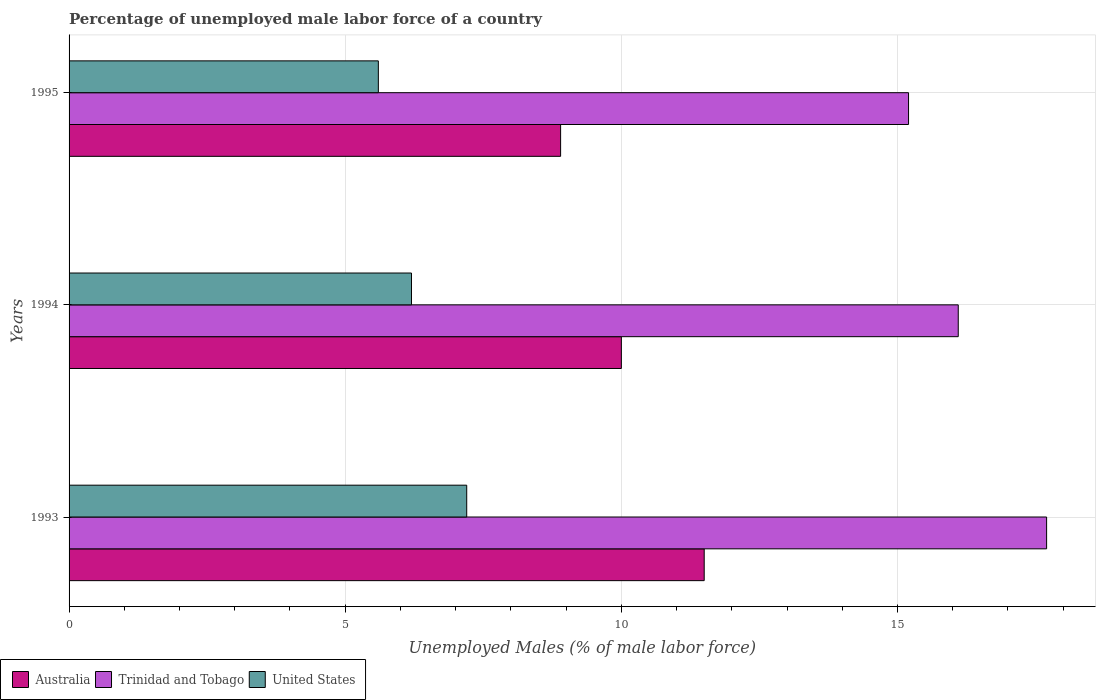How many different coloured bars are there?
Provide a succinct answer. 3. How many bars are there on the 3rd tick from the top?
Make the answer very short. 3. How many bars are there on the 3rd tick from the bottom?
Offer a very short reply. 3. In how many cases, is the number of bars for a given year not equal to the number of legend labels?
Ensure brevity in your answer.  0. What is the percentage of unemployed male labor force in United States in 1995?
Your response must be concise. 5.6. Across all years, what is the maximum percentage of unemployed male labor force in Trinidad and Tobago?
Ensure brevity in your answer.  17.7. Across all years, what is the minimum percentage of unemployed male labor force in Trinidad and Tobago?
Make the answer very short. 15.2. What is the total percentage of unemployed male labor force in Trinidad and Tobago in the graph?
Provide a succinct answer. 49. What is the difference between the percentage of unemployed male labor force in United States in 1994 and that in 1995?
Offer a terse response. 0.6. What is the difference between the percentage of unemployed male labor force in Australia in 1994 and the percentage of unemployed male labor force in Trinidad and Tobago in 1995?
Your response must be concise. -5.2. What is the average percentage of unemployed male labor force in Trinidad and Tobago per year?
Give a very brief answer. 16.33. In the year 1994, what is the difference between the percentage of unemployed male labor force in Australia and percentage of unemployed male labor force in United States?
Make the answer very short. 3.8. In how many years, is the percentage of unemployed male labor force in Australia greater than 10 %?
Your response must be concise. 1. What is the ratio of the percentage of unemployed male labor force in Trinidad and Tobago in 1993 to that in 1994?
Give a very brief answer. 1.1. Is the percentage of unemployed male labor force in Trinidad and Tobago in 1993 less than that in 1994?
Provide a short and direct response. No. What is the difference between the highest and the lowest percentage of unemployed male labor force in Trinidad and Tobago?
Provide a succinct answer. 2.5. What does the 3rd bar from the top in 1993 represents?
Your answer should be compact. Australia. What does the 1st bar from the bottom in 1994 represents?
Offer a terse response. Australia. Is it the case that in every year, the sum of the percentage of unemployed male labor force in Australia and percentage of unemployed male labor force in United States is greater than the percentage of unemployed male labor force in Trinidad and Tobago?
Make the answer very short. No. Are all the bars in the graph horizontal?
Provide a short and direct response. Yes. What is the difference between two consecutive major ticks on the X-axis?
Provide a succinct answer. 5. Does the graph contain any zero values?
Ensure brevity in your answer.  No. Does the graph contain grids?
Offer a very short reply. Yes. Where does the legend appear in the graph?
Ensure brevity in your answer.  Bottom left. What is the title of the graph?
Keep it short and to the point. Percentage of unemployed male labor force of a country. What is the label or title of the X-axis?
Ensure brevity in your answer.  Unemployed Males (% of male labor force). What is the Unemployed Males (% of male labor force) of Australia in 1993?
Your answer should be very brief. 11.5. What is the Unemployed Males (% of male labor force) in Trinidad and Tobago in 1993?
Make the answer very short. 17.7. What is the Unemployed Males (% of male labor force) in United States in 1993?
Your response must be concise. 7.2. What is the Unemployed Males (% of male labor force) in Australia in 1994?
Your answer should be compact. 10. What is the Unemployed Males (% of male labor force) of Trinidad and Tobago in 1994?
Your answer should be very brief. 16.1. What is the Unemployed Males (% of male labor force) in United States in 1994?
Make the answer very short. 6.2. What is the Unemployed Males (% of male labor force) of Australia in 1995?
Your response must be concise. 8.9. What is the Unemployed Males (% of male labor force) in Trinidad and Tobago in 1995?
Your answer should be very brief. 15.2. What is the Unemployed Males (% of male labor force) of United States in 1995?
Keep it short and to the point. 5.6. Across all years, what is the maximum Unemployed Males (% of male labor force) in Trinidad and Tobago?
Provide a succinct answer. 17.7. Across all years, what is the maximum Unemployed Males (% of male labor force) in United States?
Provide a succinct answer. 7.2. Across all years, what is the minimum Unemployed Males (% of male labor force) in Australia?
Provide a short and direct response. 8.9. Across all years, what is the minimum Unemployed Males (% of male labor force) in Trinidad and Tobago?
Provide a short and direct response. 15.2. Across all years, what is the minimum Unemployed Males (% of male labor force) in United States?
Your response must be concise. 5.6. What is the total Unemployed Males (% of male labor force) of Australia in the graph?
Make the answer very short. 30.4. What is the difference between the Unemployed Males (% of male labor force) of United States in 1993 and that in 1994?
Provide a short and direct response. 1. What is the difference between the Unemployed Males (% of male labor force) in United States in 1993 and that in 1995?
Your response must be concise. 1.6. What is the difference between the Unemployed Males (% of male labor force) in United States in 1994 and that in 1995?
Your answer should be compact. 0.6. What is the difference between the Unemployed Males (% of male labor force) of Australia in 1993 and the Unemployed Males (% of male labor force) of Trinidad and Tobago in 1994?
Offer a terse response. -4.6. What is the difference between the Unemployed Males (% of male labor force) of Trinidad and Tobago in 1993 and the Unemployed Males (% of male labor force) of United States in 1994?
Offer a terse response. 11.5. What is the difference between the Unemployed Males (% of male labor force) in Australia in 1993 and the Unemployed Males (% of male labor force) in Trinidad and Tobago in 1995?
Make the answer very short. -3.7. What is the difference between the Unemployed Males (% of male labor force) of Trinidad and Tobago in 1993 and the Unemployed Males (% of male labor force) of United States in 1995?
Give a very brief answer. 12.1. What is the difference between the Unemployed Males (% of male labor force) in Australia in 1994 and the Unemployed Males (% of male labor force) in Trinidad and Tobago in 1995?
Give a very brief answer. -5.2. What is the difference between the Unemployed Males (% of male labor force) of Trinidad and Tobago in 1994 and the Unemployed Males (% of male labor force) of United States in 1995?
Your response must be concise. 10.5. What is the average Unemployed Males (% of male labor force) of Australia per year?
Make the answer very short. 10.13. What is the average Unemployed Males (% of male labor force) in Trinidad and Tobago per year?
Provide a short and direct response. 16.33. What is the average Unemployed Males (% of male labor force) in United States per year?
Make the answer very short. 6.33. In the year 1993, what is the difference between the Unemployed Males (% of male labor force) of Australia and Unemployed Males (% of male labor force) of United States?
Your answer should be very brief. 4.3. In the year 1994, what is the difference between the Unemployed Males (% of male labor force) of Australia and Unemployed Males (% of male labor force) of Trinidad and Tobago?
Your answer should be compact. -6.1. In the year 1994, what is the difference between the Unemployed Males (% of male labor force) of Australia and Unemployed Males (% of male labor force) of United States?
Your response must be concise. 3.8. In the year 1994, what is the difference between the Unemployed Males (% of male labor force) in Trinidad and Tobago and Unemployed Males (% of male labor force) in United States?
Keep it short and to the point. 9.9. In the year 1995, what is the difference between the Unemployed Males (% of male labor force) of Trinidad and Tobago and Unemployed Males (% of male labor force) of United States?
Offer a terse response. 9.6. What is the ratio of the Unemployed Males (% of male labor force) of Australia in 1993 to that in 1994?
Your response must be concise. 1.15. What is the ratio of the Unemployed Males (% of male labor force) of Trinidad and Tobago in 1993 to that in 1994?
Ensure brevity in your answer.  1.1. What is the ratio of the Unemployed Males (% of male labor force) in United States in 1993 to that in 1994?
Your answer should be compact. 1.16. What is the ratio of the Unemployed Males (% of male labor force) in Australia in 1993 to that in 1995?
Provide a succinct answer. 1.29. What is the ratio of the Unemployed Males (% of male labor force) of Trinidad and Tobago in 1993 to that in 1995?
Your answer should be very brief. 1.16. What is the ratio of the Unemployed Males (% of male labor force) in United States in 1993 to that in 1995?
Provide a succinct answer. 1.29. What is the ratio of the Unemployed Males (% of male labor force) in Australia in 1994 to that in 1995?
Provide a short and direct response. 1.12. What is the ratio of the Unemployed Males (% of male labor force) of Trinidad and Tobago in 1994 to that in 1995?
Provide a short and direct response. 1.06. What is the ratio of the Unemployed Males (% of male labor force) in United States in 1994 to that in 1995?
Ensure brevity in your answer.  1.11. What is the difference between the highest and the second highest Unemployed Males (% of male labor force) of Australia?
Keep it short and to the point. 1.5. What is the difference between the highest and the lowest Unemployed Males (% of male labor force) of Australia?
Offer a terse response. 2.6. What is the difference between the highest and the lowest Unemployed Males (% of male labor force) of Trinidad and Tobago?
Make the answer very short. 2.5. 